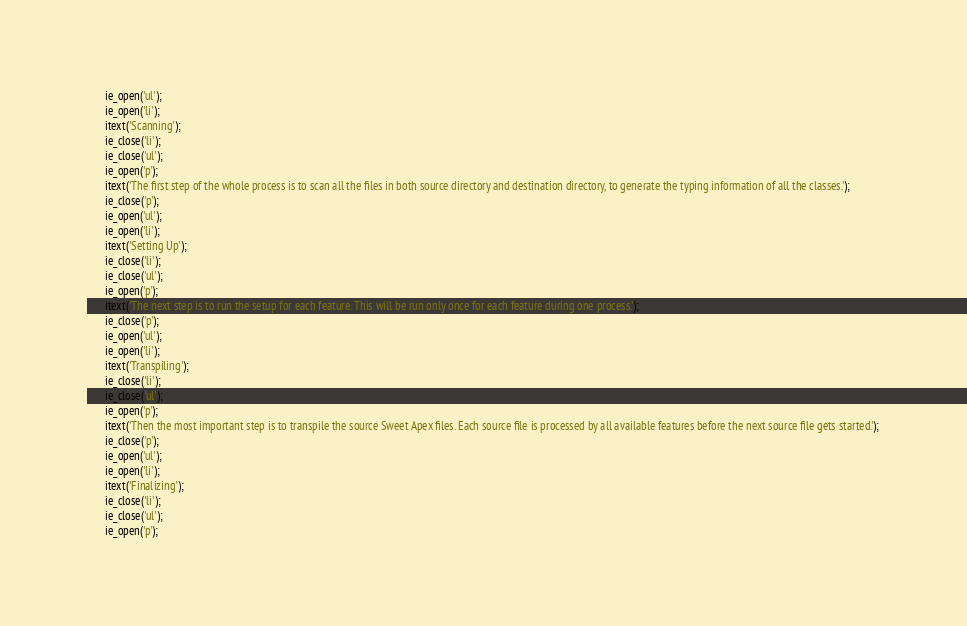Convert code to text. <code><loc_0><loc_0><loc_500><loc_500><_JavaScript_>      ie_open('ul');
      ie_open('li');
      itext('Scanning');
      ie_close('li');
      ie_close('ul');
      ie_open('p');
      itext('The first step of the whole process is to scan all the files in both source directory and destination directory, to generate the typing information of all the classes.');
      ie_close('p');
      ie_open('ul');
      ie_open('li');
      itext('Setting Up');
      ie_close('li');
      ie_close('ul');
      ie_open('p');
      itext('The next step is to run the setup for each feature. This will be run only once for each feature during one process.');
      ie_close('p');
      ie_open('ul');
      ie_open('li');
      itext('Transpiling');
      ie_close('li');
      ie_close('ul');
      ie_open('p');
      itext('Then the most important step is to transpile the source Sweet Apex files. Each source file is processed by all available features before the next source file gets started.');
      ie_close('p');
      ie_open('ul');
      ie_open('li');
      itext('Finalizing');
      ie_close('li');
      ie_close('ul');
      ie_open('p');</code> 